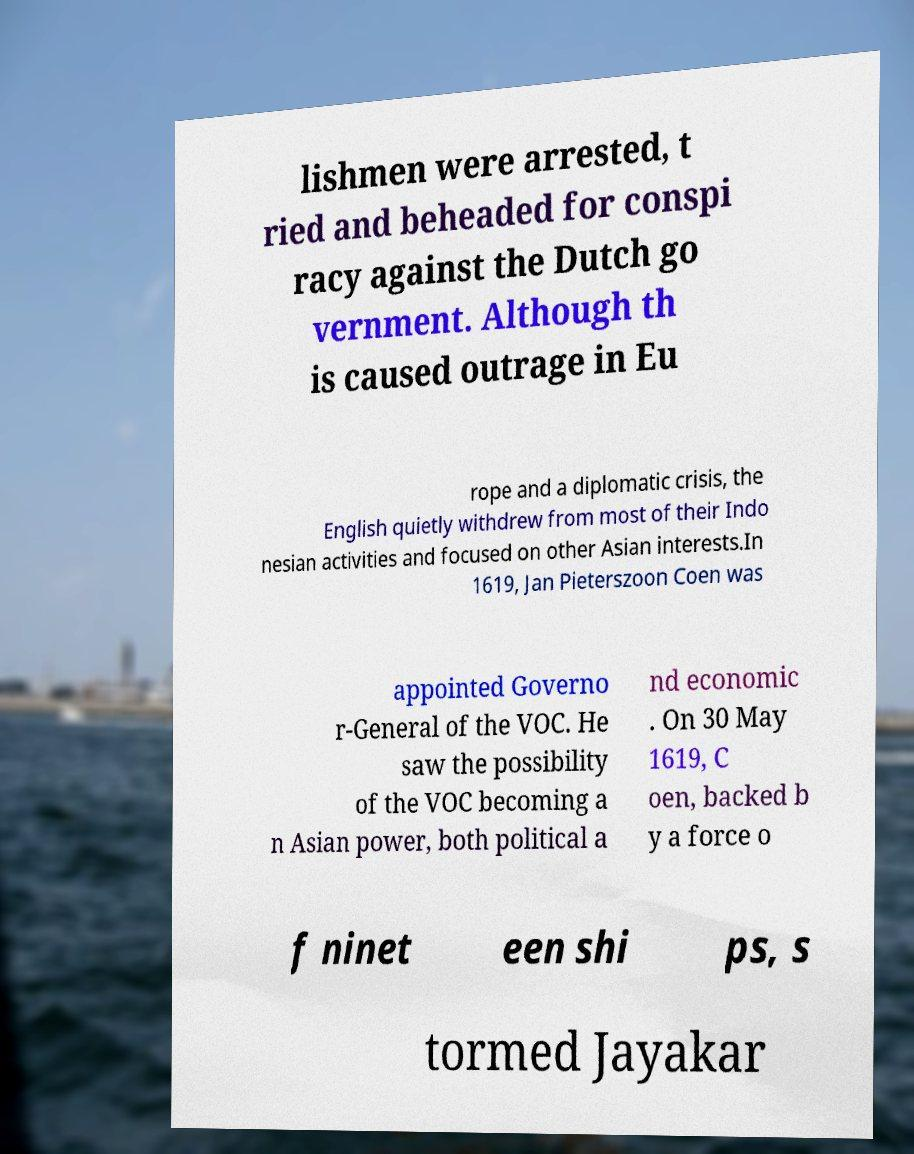Can you read and provide the text displayed in the image?This photo seems to have some interesting text. Can you extract and type it out for me? lishmen were arrested, t ried and beheaded for conspi racy against the Dutch go vernment. Although th is caused outrage in Eu rope and a diplomatic crisis, the English quietly withdrew from most of their Indo nesian activities and focused on other Asian interests.In 1619, Jan Pieterszoon Coen was appointed Governo r-General of the VOC. He saw the possibility of the VOC becoming a n Asian power, both political a nd economic . On 30 May 1619, C oen, backed b y a force o f ninet een shi ps, s tormed Jayakar 